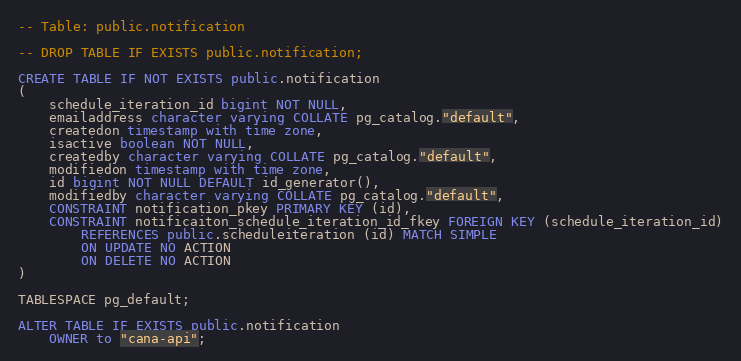Convert code to text. <code><loc_0><loc_0><loc_500><loc_500><_SQL_>-- Table: public.notification

-- DROP TABLE IF EXISTS public.notification;

CREATE TABLE IF NOT EXISTS public.notification
(
    schedule_iteration_id bigint NOT NULL,
    emailaddress character varying COLLATE pg_catalog."default",
    createdon timestamp with time zone,
    isactive boolean NOT NULL,
    createdby character varying COLLATE pg_catalog."default",
    modifiedon timestamp with time zone,
    id bigint NOT NULL DEFAULT id_generator(),
    modifiedby character varying COLLATE pg_catalog."default",
    CONSTRAINT notification_pkey PRIMARY KEY (id),
    CONSTRAINT notificaiton_schedule_iteration_id_fkey FOREIGN KEY (schedule_iteration_id)
        REFERENCES public.scheduleiteration (id) MATCH SIMPLE
        ON UPDATE NO ACTION
        ON DELETE NO ACTION
)

TABLESPACE pg_default;

ALTER TABLE IF EXISTS public.notification
    OWNER to "cana-api";</code> 